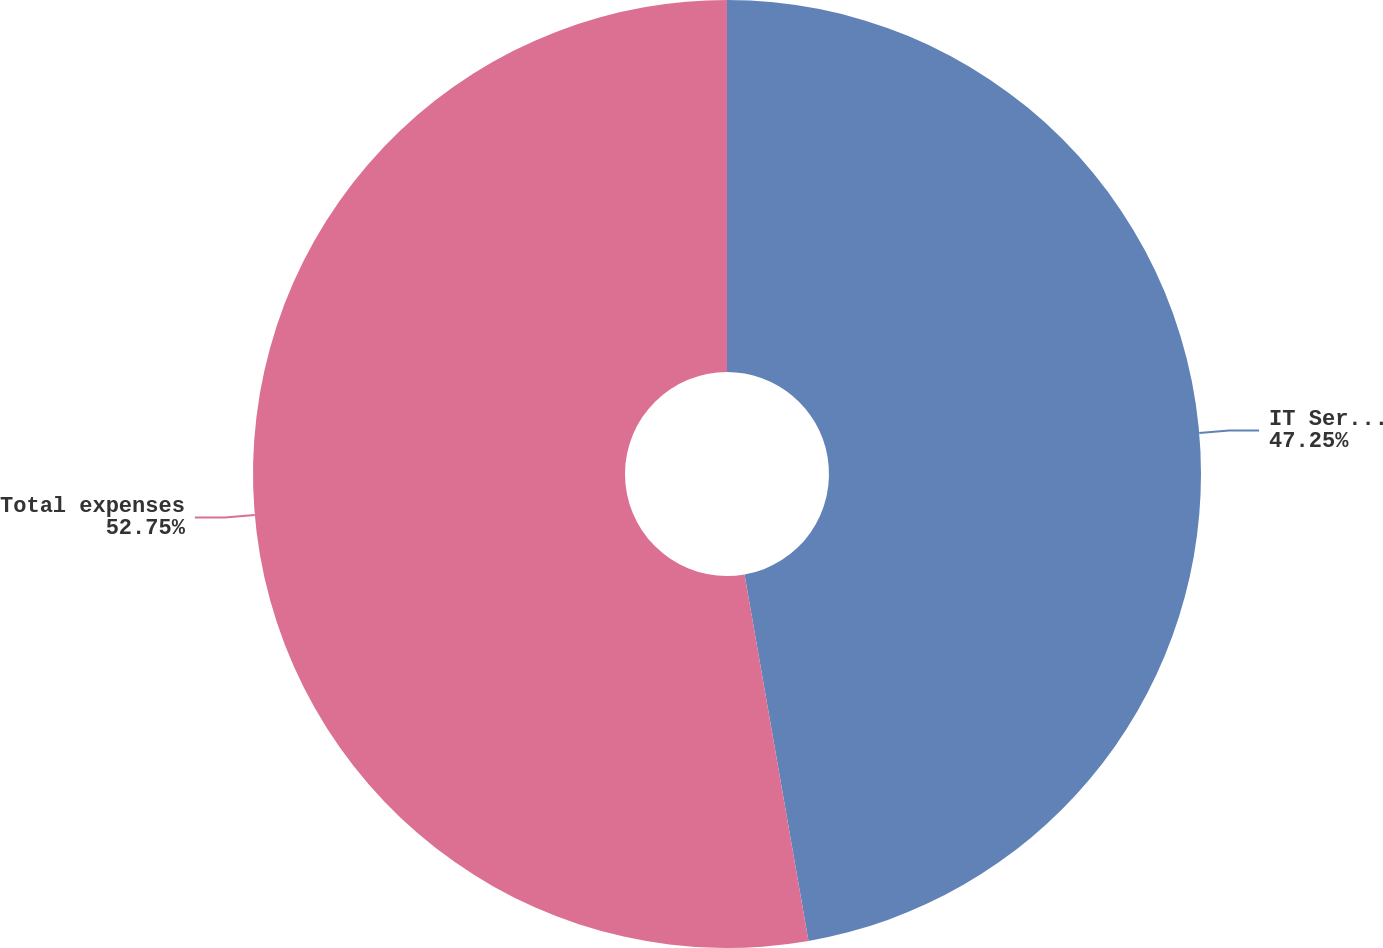Convert chart. <chart><loc_0><loc_0><loc_500><loc_500><pie_chart><fcel>IT Services Agreement<fcel>Total expenses<nl><fcel>47.25%<fcel>52.75%<nl></chart> 